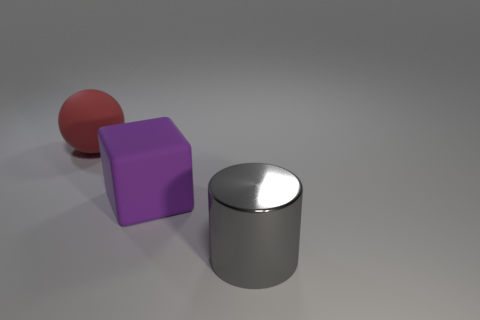Add 3 big red cylinders. How many objects exist? 6 Subtract all cylinders. How many objects are left? 2 Subtract all matte balls. Subtract all balls. How many objects are left? 1 Add 2 big red balls. How many big red balls are left? 3 Add 1 red objects. How many red objects exist? 2 Subtract 1 purple blocks. How many objects are left? 2 